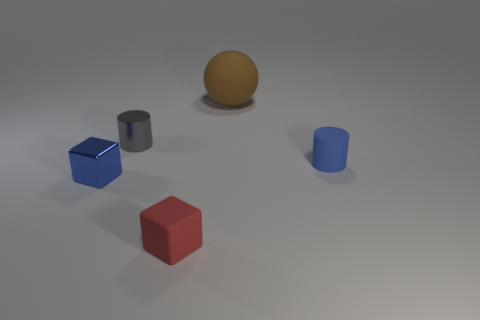Add 3 tiny blue metallic blocks. How many objects exist? 8 Subtract all blocks. How many objects are left? 3 Subtract 1 balls. How many balls are left? 0 Subtract all blue balls. Subtract all yellow cubes. How many balls are left? 1 Subtract all blue cubes. How many yellow cylinders are left? 0 Subtract all tiny blue cylinders. Subtract all metal cubes. How many objects are left? 3 Add 4 brown matte balls. How many brown matte balls are left? 5 Add 4 tiny shiny cubes. How many tiny shiny cubes exist? 5 Subtract all blue cubes. How many cubes are left? 1 Subtract 0 cyan blocks. How many objects are left? 5 